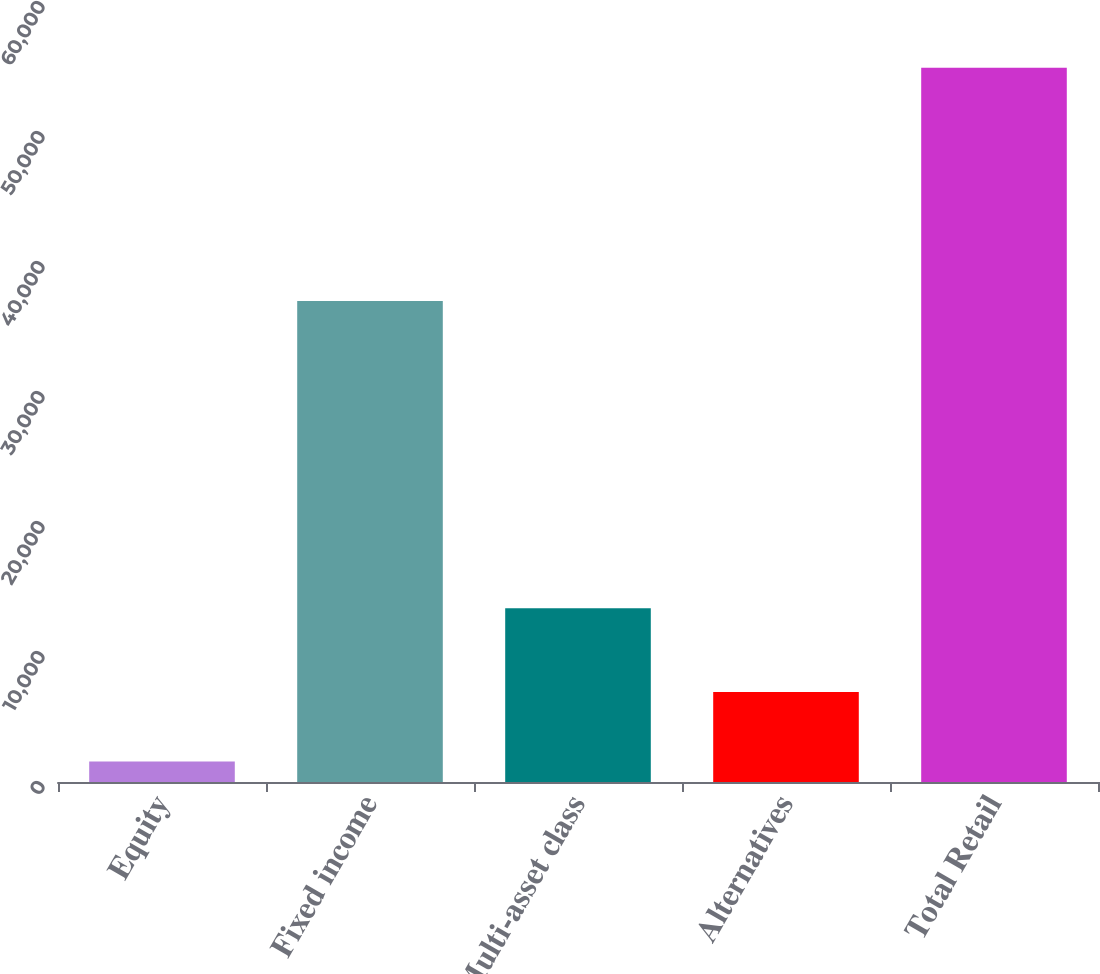Convert chart. <chart><loc_0><loc_0><loc_500><loc_500><bar_chart><fcel>Equity<fcel>Fixed income<fcel>Multi-asset class<fcel>Alternatives<fcel>Total Retail<nl><fcel>1582<fcel>36995<fcel>13366<fcel>6918.2<fcel>54944<nl></chart> 